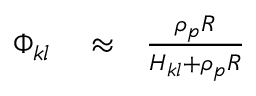<formula> <loc_0><loc_0><loc_500><loc_500>\begin{array} { r l r } { \Phi _ { k l } } & \approx } & { \frac { \rho _ { p } R } { H _ { k l } + \rho _ { p } R } } \end{array}</formula> 